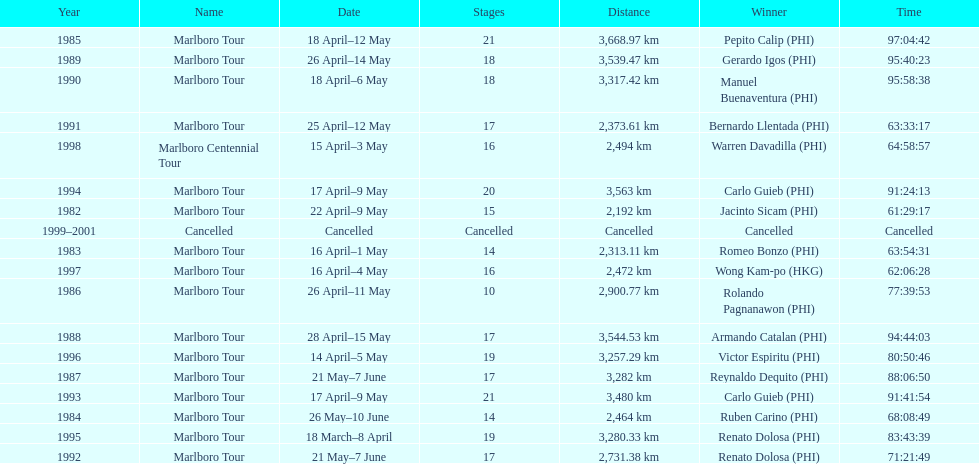Who was the only winner to have their time below 61:45:00? Jacinto Sicam. 